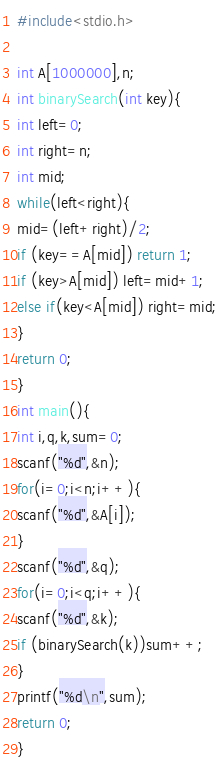Convert code to text. <code><loc_0><loc_0><loc_500><loc_500><_C_>#include<stdio.h>

int A[1000000],n;
int binarySearch(int key){
int left=0;
int right=n;
int mid;
while(left<right){
mid=(left+right)/2;
if (key==A[mid]) return 1;
if (key>A[mid]) left=mid+1;
else if(key<A[mid]) right=mid;
}
return 0;
}
int main(){
int i,q,k,sum=0;
scanf("%d",&n);
for(i=0;i<n;i++){
scanf("%d",&A[i]);
}
scanf("%d",&q);
for(i=0;i<q;i++){
scanf("%d",&k);
if (binarySearch(k))sum++;
}
printf("%d\n",sum);
return 0;
}</code> 